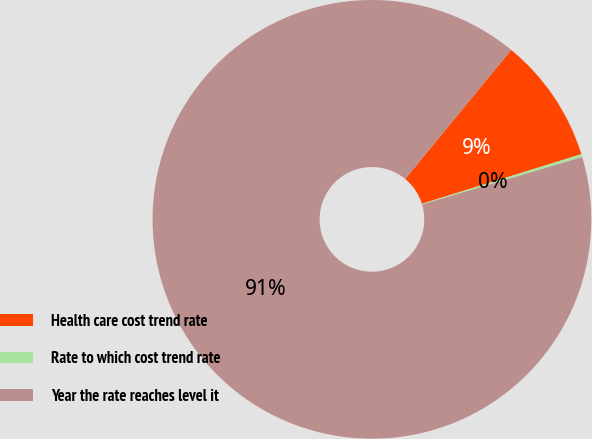Convert chart. <chart><loc_0><loc_0><loc_500><loc_500><pie_chart><fcel>Health care cost trend rate<fcel>Rate to which cost trend rate<fcel>Year the rate reaches level it<nl><fcel>9.25%<fcel>0.22%<fcel>90.52%<nl></chart> 